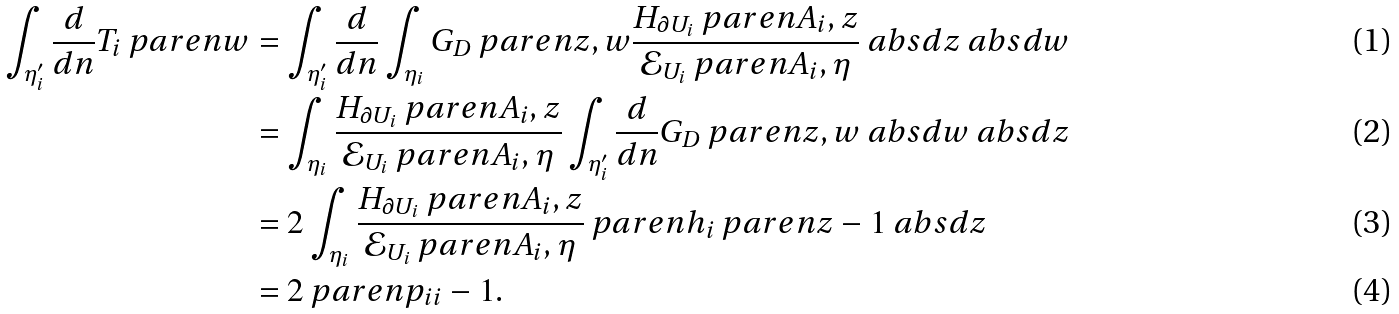Convert formula to latex. <formula><loc_0><loc_0><loc_500><loc_500>\int _ { \eta ^ { \prime } _ { i } } \frac { d } { d n } T _ { i } \ p a r e n { w } & = \int _ { \eta ^ { \prime } _ { i } } \frac { d } { d n } \int _ { \eta _ { i } } G _ { D } \ p a r e n { z , w } \frac { H _ { \partial U _ { i } } \ p a r e n { A _ { i } , z } } { \mathcal { E } _ { U _ { i } } \ p a r e n { A _ { i } , \eta } } \ a b s { d z } \ a b s { d w } \\ & = \int _ { \eta _ { i } } \frac { H _ { \partial U _ { i } } \ p a r e n { A _ { i } , z } } { \mathcal { E } _ { U _ { i } } \ p a r e n { A _ { i } , \eta } } \int _ { \eta ^ { \prime } _ { i } } \frac { d } { d n } G _ { D } \ p a r e n { z , w } \ a b s { d w } \ a b s { d z } \\ & = 2 \int _ { \eta _ { i } } \frac { H _ { \partial U _ { i } } \ p a r e n { A _ { i } , z } } { \mathcal { E } _ { U _ { i } } \ p a r e n { A _ { i } , \eta } } \ p a r e n { h _ { i } \ p a r e n { z } - 1 } \ a b s { d z } \\ & = 2 \ p a r e n { p _ { i i } - 1 } .</formula> 